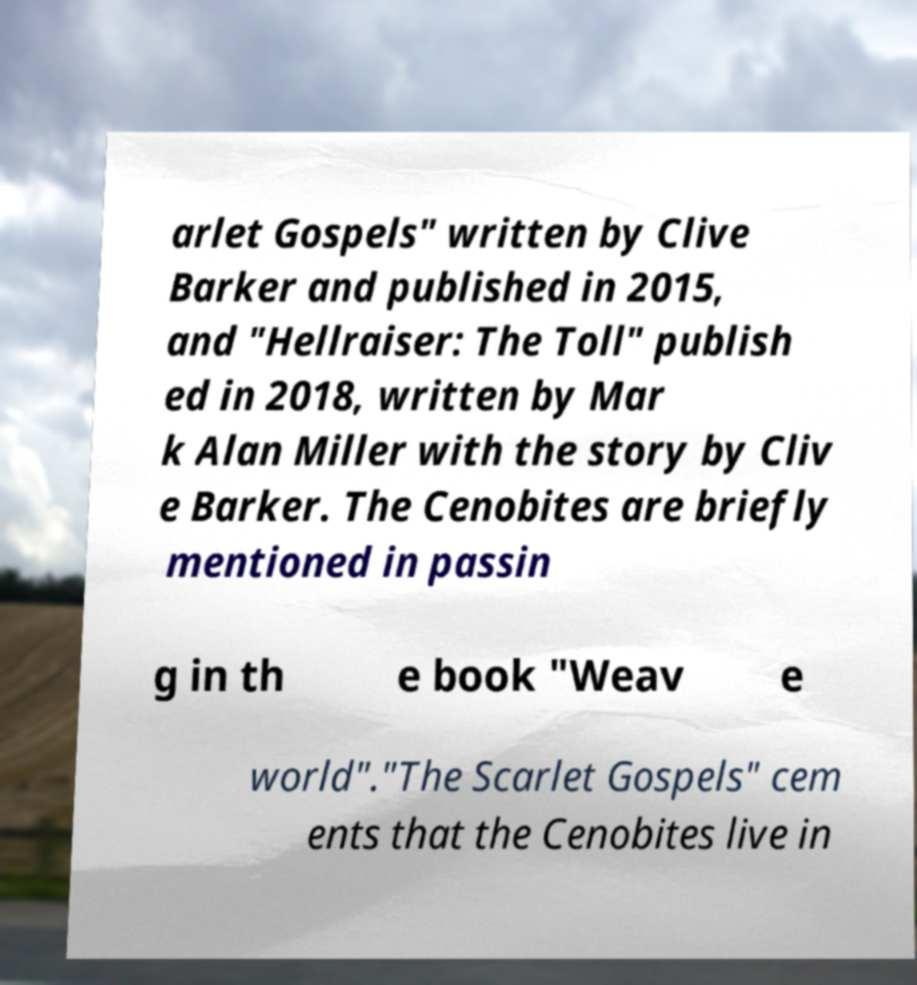There's text embedded in this image that I need extracted. Can you transcribe it verbatim? arlet Gospels" written by Clive Barker and published in 2015, and "Hellraiser: The Toll" publish ed in 2018, written by Mar k Alan Miller with the story by Cliv e Barker. The Cenobites are briefly mentioned in passin g in th e book "Weav e world"."The Scarlet Gospels" cem ents that the Cenobites live in 